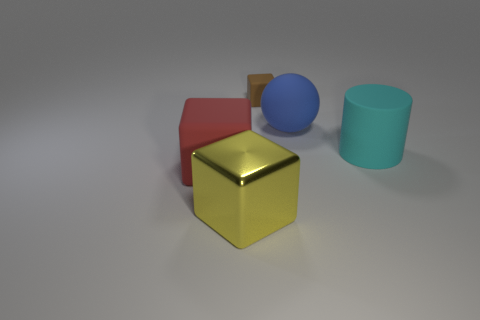Subtract all rubber blocks. How many blocks are left? 1 Subtract 1 cubes. How many cubes are left? 2 Add 5 rubber cubes. How many objects exist? 10 Subtract all cubes. How many objects are left? 2 Subtract all large blue spheres. Subtract all blue matte objects. How many objects are left? 3 Add 1 tiny brown things. How many tiny brown things are left? 2 Add 2 red matte objects. How many red matte objects exist? 3 Subtract 0 gray balls. How many objects are left? 5 